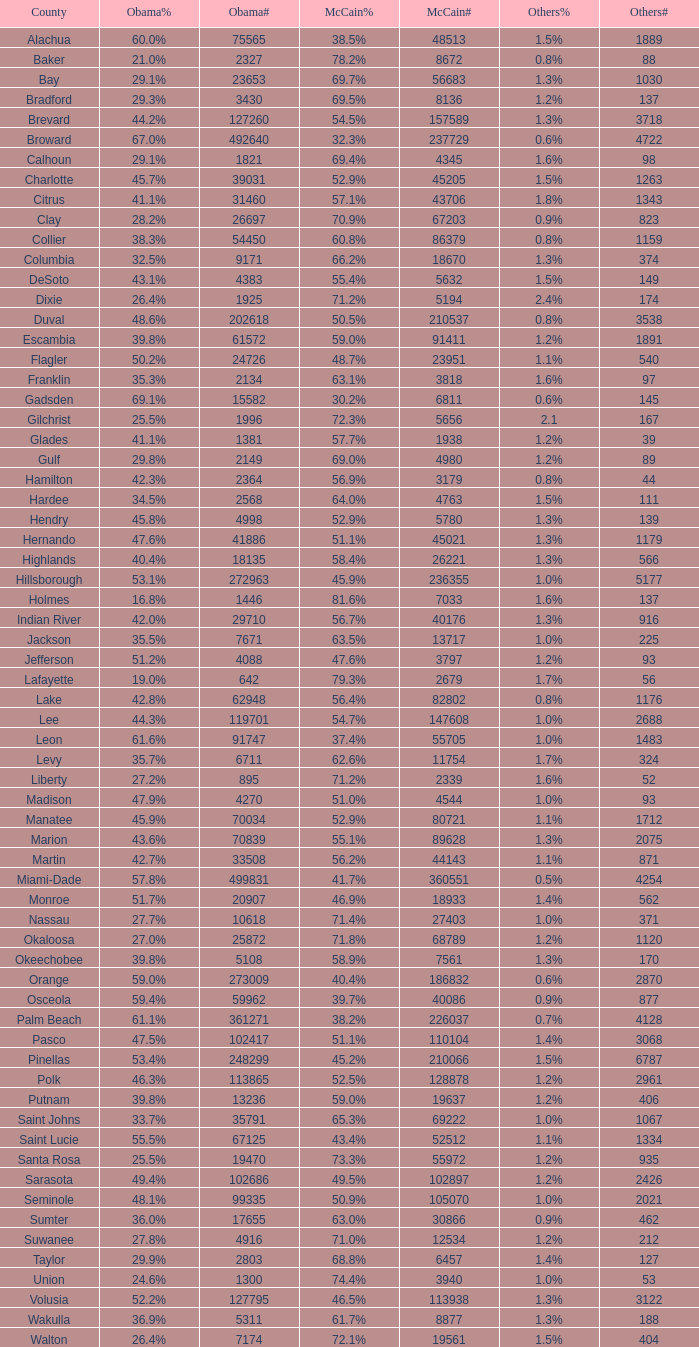What percentage was the others vote when McCain had 52.9% and less than 45205.0 voters? 1.3%. 